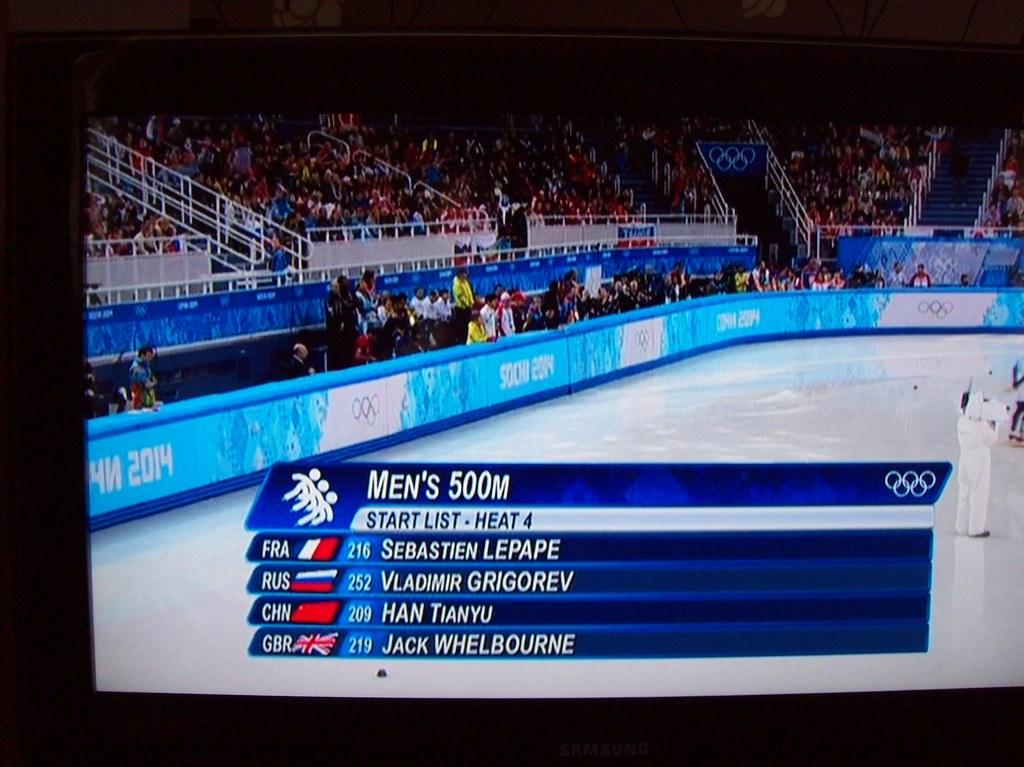<image>
Describe the image concisely. A rink is shown with MEN'S 500m on the screen and listing names including SEBASTIAN LEPAPE, VLADIMIR GRIGOREV, and HAN TIANYU. 